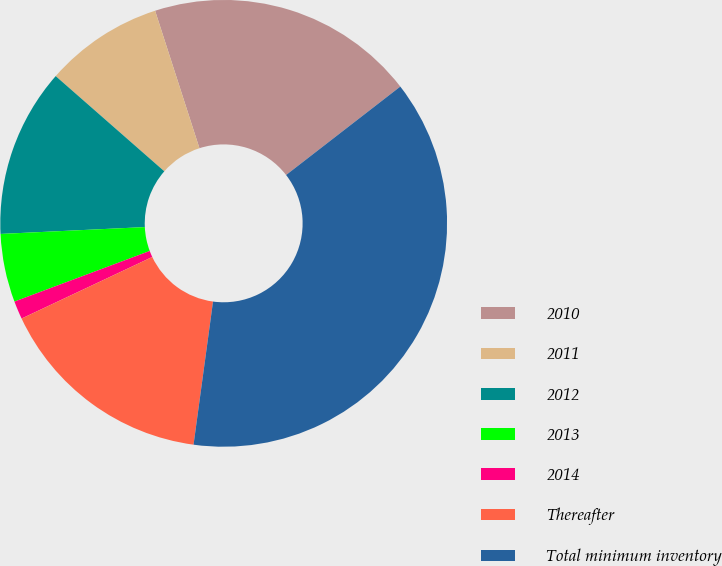Convert chart. <chart><loc_0><loc_0><loc_500><loc_500><pie_chart><fcel>2010<fcel>2011<fcel>2012<fcel>2013<fcel>2014<fcel>Thereafter<fcel>Total minimum inventory<nl><fcel>19.48%<fcel>8.58%<fcel>12.21%<fcel>4.94%<fcel>1.31%<fcel>15.84%<fcel>37.64%<nl></chart> 